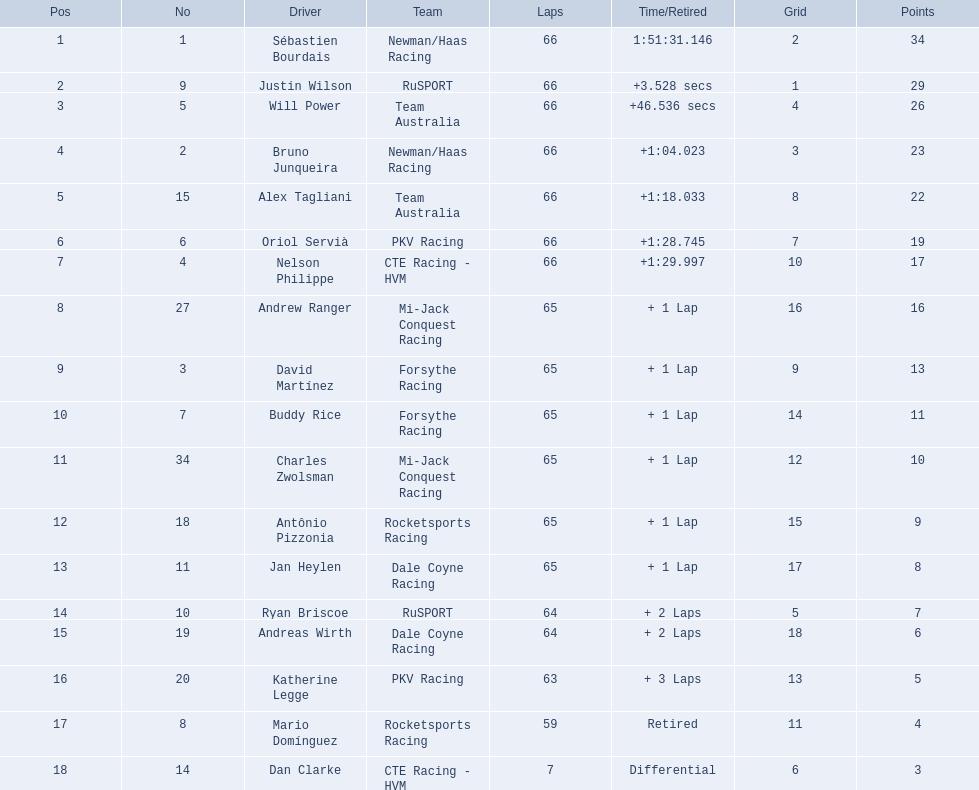What drivers commenced the race within the top 10? Sébastien Bourdais, Justin Wilson, Will Power, Bruno Junqueira, Alex Tagliani, Oriol Servià, Nelson Philippe, Ryan Briscoe, Dan Clarke. Out of them, who completed the entire 66 laps? Sébastien Bourdais, Justin Wilson, Will Power, Bruno Junqueira, Alex Tagliani, Oriol Servià, Nelson Philippe. Who among them wasn't a part of team australia? Sébastien Bourdais, Justin Wilson, Bruno Junqueira, Oriol Servià, Nelson Philippe. Which drivers had a finish time more than a minute after the first-place winner? Bruno Junqueira, Oriol Servià, Nelson Philippe. Who had the greatest car number among these racers? Oriol Servià. 